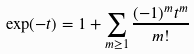<formula> <loc_0><loc_0><loc_500><loc_500>\exp ( - t ) = 1 + \sum _ { m \geq 1 } \frac { ( - 1 ) ^ { m } t ^ { m } } { m ! }</formula> 